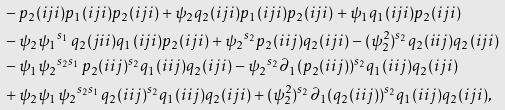<formula> <loc_0><loc_0><loc_500><loc_500>& - p _ { 2 } ( i j i ) p _ { 1 } ( i j i ) p _ { 2 } ( i j i ) + \psi _ { 2 } q _ { 2 } ( i j i ) p _ { 1 } ( i j i ) p _ { 2 } ( i j i ) + \psi _ { 1 } q _ { 1 } ( i j i ) p _ { 2 } ( i j i ) \\ & - \psi _ { 2 } \psi _ { 1 } { ^ { s _ { 1 } \, } } q _ { 2 } ( j i i ) q _ { 1 } ( i j i ) p _ { 2 } ( i j i ) + \psi _ { 2 } { ^ { s _ { 2 } } } p _ { 2 } ( i i j ) q _ { 2 } ( i j i ) - ( \psi _ { 2 } ^ { 2 } ) { ^ { s _ { 2 } } } q _ { 2 } ( i i j ) q _ { 2 } ( i j i ) \\ & - \psi _ { 1 } \psi _ { 2 } { ^ { s _ { 2 } s _ { 1 } \, } } p _ { 2 } ( i i j ) { ^ { s _ { 2 } } } q _ { 1 } ( i i j ) q _ { 2 } ( i j i ) - \psi _ { 2 } { ^ { s _ { 2 } } } \partial _ { 1 } ( p _ { 2 } ( i i j ) ) { ^ { s _ { 2 } } } q _ { 1 } ( i i j ) q _ { 2 } ( i j i ) \\ & + \psi _ { 2 } \psi _ { 1 } \psi _ { 2 } { ^ { s _ { 2 } s _ { 1 } \, } } q _ { 2 } ( i i j ) { ^ { s _ { 2 } } } q _ { 1 } ( i i j ) q _ { 2 } ( i j i ) + ( \psi _ { 2 } ^ { 2 } ) { ^ { s _ { 2 } } } \partial _ { 1 } ( q _ { 2 } ( i i j ) ) { ^ { s _ { 2 } } } q _ { 1 } ( i i j ) q _ { 2 } ( i j i ) ,</formula> 